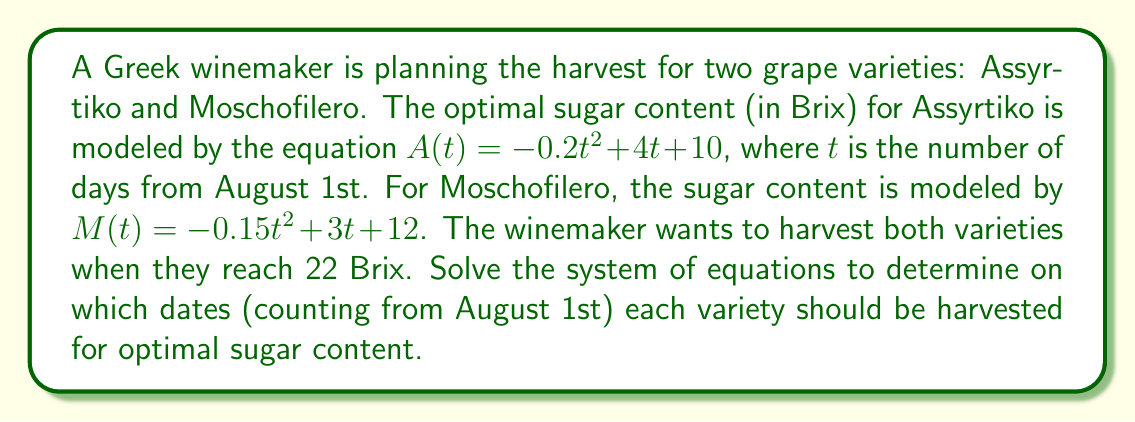Give your solution to this math problem. Let's approach this step-by-step:

1) We need to solve two equations:
   $A(t) = 22$ for Assyrtiko
   $M(t) = 22$ for Moschofilero

2) For Assyrtiko:
   $-0.2t^2 + 4t + 10 = 22$
   $-0.2t^2 + 4t - 12 = 0$

3) For Moschofilero:
   $-0.15t^2 + 3t + 12 = 22$
   $-0.15t^2 + 3t - 10 = 0$

4) Let's solve the Assyrtiko equation first using the quadratic formula:
   $t = \frac{-b \pm \sqrt{b^2 - 4ac}}{2a}$

   Where $a = -0.2$, $b = 4$, and $c = -12$

   $t = \frac{-4 \pm \sqrt{16 - 4(-0.2)(-12)}}{2(-0.2)}$
   $t = \frac{-4 \pm \sqrt{16 - 9.6}}{-0.4}$
   $t = \frac{-4 \pm \sqrt{6.4}}{-0.4}$
   $t = \frac{-4 \pm 2.53}{-0.4}$

   This gives us two solutions:
   $t_1 = \frac{-4 + 2.53}{-0.4} \approx 3.68$
   $t_2 = \frac{-4 - 2.53}{-0.4} \approx 16.32$

   Since we're counting days from August 1st, we round to the nearest whole day: 4 or 16.
   The earlier date (4) makes more sense for grape harvesting.

5) Now for Moschofilero:
   Using the quadratic formula with $a = -0.15$, $b = 3$, and $c = -10$:

   $t = \frac{-3 \pm \sqrt{9 - 4(-0.15)(-10)}}{2(-0.15)}$
   $t = \frac{-3 \pm \sqrt{9 - 6}}{-0.3}$
   $t = \frac{-3 \pm \sqrt{3}}{-0.3}$

   This gives us:
   $t_1 = \frac{-3 + 1.73}{-0.3} \approx 4.23$
   $t_2 = \frac{-3 - 1.73}{-0.3} \approx 15.77$

   Rounding to the nearest whole day: 4 or 16.
   Again, the earlier date (4) is more appropriate for grape harvesting.
Answer: Assyrtiko should be harvested on August 5th (4 days from August 1st), and Moschofilero should be harvested on August 5th as well (4 days from August 1st). 